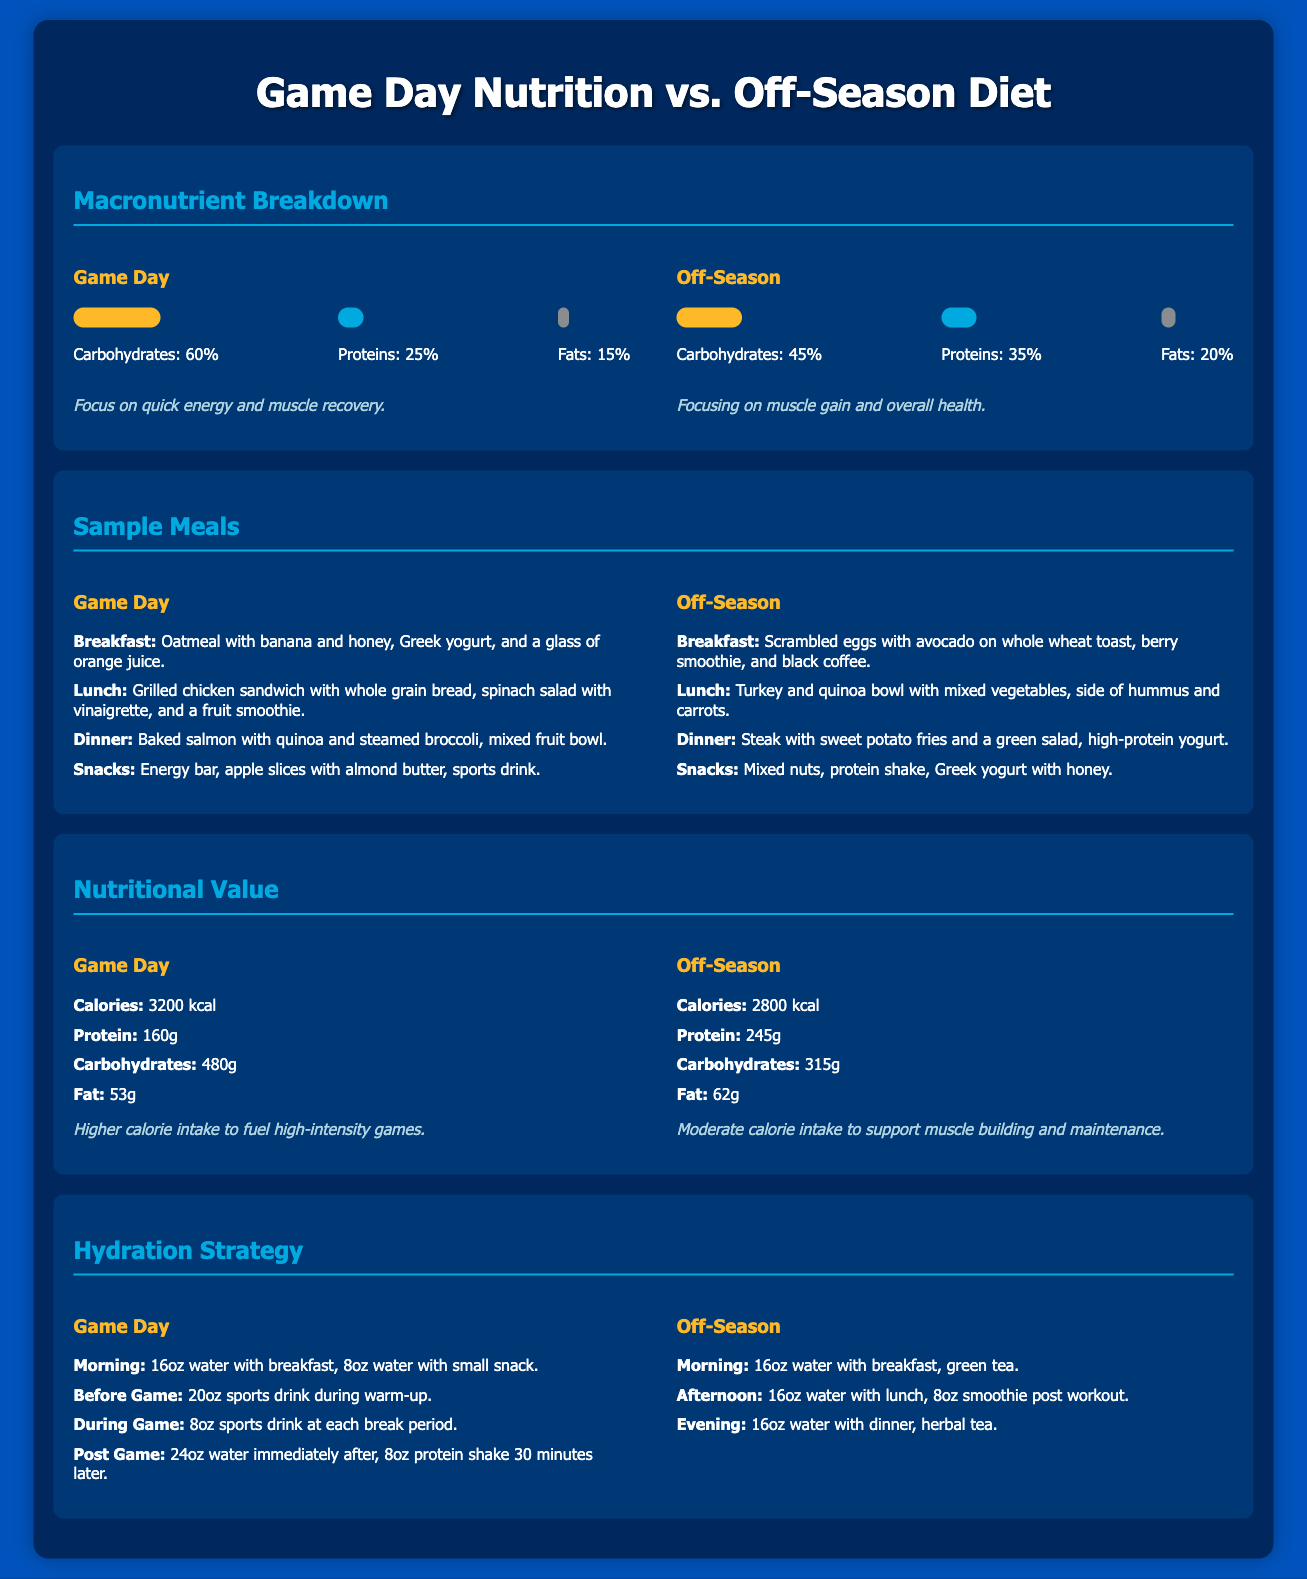What is the percentage of carbohydrates in the Game Day nutrition? The document states that carbohydrates constitute 60% of the macronutrient breakdown for Game Day nutrition.
Answer: 60% What is the primary focus of the Off-Season diet? The note in the Off-Season section indicates that the focus is on muscle gain and overall health.
Answer: Muscle gain and overall health How many grams of protein are in the Off-Season diet? The Off-Season nutritional value section lists protein content as 245g.
Answer: 245g What is the total calorie intake on Game Day? The document specifies the calorie intake for Game Day as 3200 kcal.
Answer: 3200 kcal What type of drink is consumed during warm-up on Game Day? The Game Day hydration strategy mentions consumption of a sports drink during warm-up.
Answer: Sports drink How much fat is consumed on Game Day? The nutritional value for Game Day indicates fat consumption is 53g.
Answer: 53g What is the recommended morning hydration for both Game Day and Off-Season? Both sections indicate that 16oz water is consumed with breakfast in the morning hydration strategy.
Answer: 16oz water What is the main meal component of the Game Day lunch? The Game Day sample meal section lists a grilled chicken sandwich as the main component of lunch.
Answer: Grilled chicken sandwich Which macronutrient is highest in the Off-Season diet? The Off-Season macronutrient breakdown shows that protein is the highest at 35%.
Answer: Protein How does the calorie intake on Game Day compare to the Off-Season diet? The calorie intake for Game Day (3200 kcal) is higher compared to the Off-Season diet (2800 kcal), indicating more calories are needed for high-intensity games.
Answer: Higher 